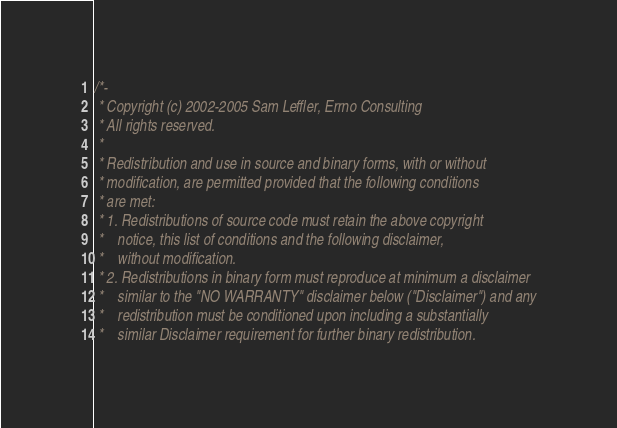Convert code to text. <code><loc_0><loc_0><loc_500><loc_500><_C_>/*-
 * Copyright (c) 2002-2005 Sam Leffler, Errno Consulting
 * All rights reserved.
 *
 * Redistribution and use in source and binary forms, with or without
 * modification, are permitted provided that the following conditions
 * are met:
 * 1. Redistributions of source code must retain the above copyright
 *    notice, this list of conditions and the following disclaimer,
 *    without modification.
 * 2. Redistributions in binary form must reproduce at minimum a disclaimer
 *    similar to the "NO WARRANTY" disclaimer below ("Disclaimer") and any
 *    redistribution must be conditioned upon including a substantially
 *    similar Disclaimer requirement for further binary redistribution.</code> 